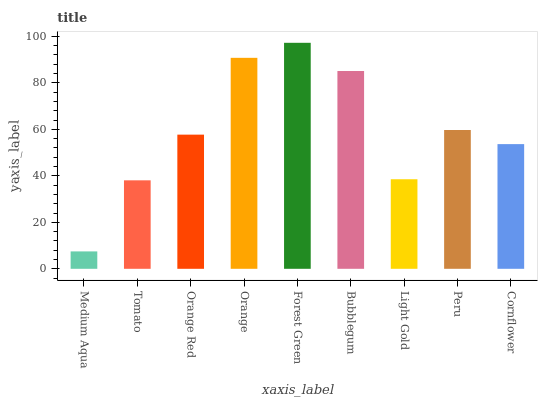Is Medium Aqua the minimum?
Answer yes or no. Yes. Is Forest Green the maximum?
Answer yes or no. Yes. Is Tomato the minimum?
Answer yes or no. No. Is Tomato the maximum?
Answer yes or no. No. Is Tomato greater than Medium Aqua?
Answer yes or no. Yes. Is Medium Aqua less than Tomato?
Answer yes or no. Yes. Is Medium Aqua greater than Tomato?
Answer yes or no. No. Is Tomato less than Medium Aqua?
Answer yes or no. No. Is Orange Red the high median?
Answer yes or no. Yes. Is Orange Red the low median?
Answer yes or no. Yes. Is Cornflower the high median?
Answer yes or no. No. Is Bubblegum the low median?
Answer yes or no. No. 